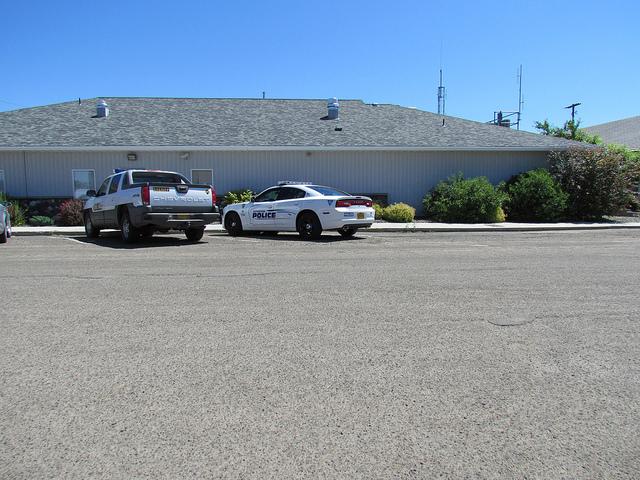What are on the back of the trucks?
Answer briefly. Nothing. Did the cops pull over the truck?
Keep it brief. No. Sunny or overcast?
Be succinct. Sunny. What color is the ground?
Concise answer only. Gray. What kind of vehicle is pictured?
Give a very brief answer. Car. Is this a bus station?
Answer briefly. No. Are any of the cars yellow?
Short answer required. No. What type and model is the car?
Quick response, please. Dodge charger. The car is parked by what?
Concise answer only. Truck. Is one of the buildings checkered in color?
Write a very short answer. No. What animals are on top of the car?
Be succinct. None. Is this a camping site?
Give a very brief answer. No. What color is the truck?
Concise answer only. White. Is the police car parked on an angle?
Quick response, please. Yes. Are there clouds in the sky?
Be succinct. No. Is that a traveling bus?
Quick response, please. No. 